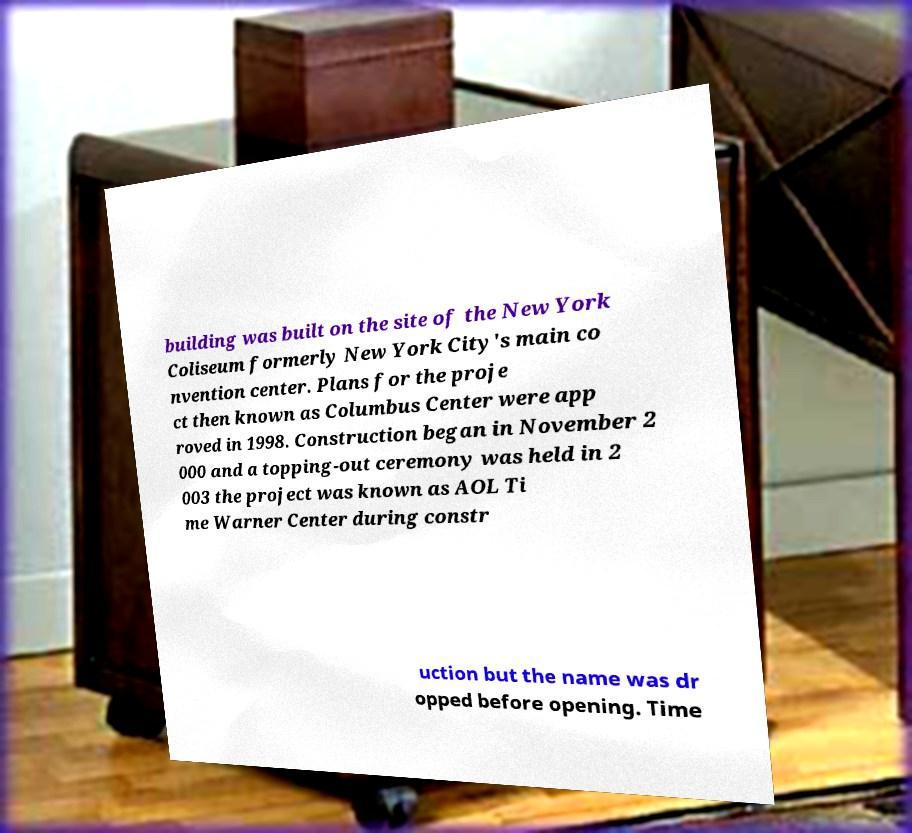I need the written content from this picture converted into text. Can you do that? building was built on the site of the New York Coliseum formerly New York City's main co nvention center. Plans for the proje ct then known as Columbus Center were app roved in 1998. Construction began in November 2 000 and a topping-out ceremony was held in 2 003 the project was known as AOL Ti me Warner Center during constr uction but the name was dr opped before opening. Time 